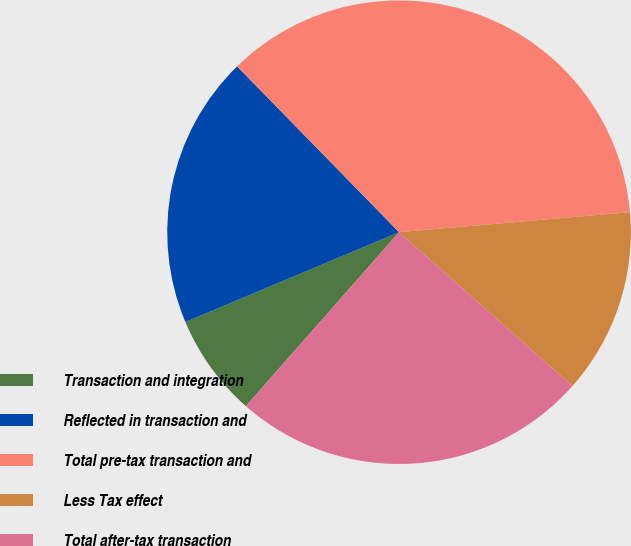<chart> <loc_0><loc_0><loc_500><loc_500><pie_chart><fcel>Transaction and integration<fcel>Reflected in transaction and<fcel>Total pre-tax transaction and<fcel>Less Tax effect<fcel>Total after-tax transaction<nl><fcel>7.18%<fcel>19.02%<fcel>35.94%<fcel>12.93%<fcel>24.94%<nl></chart> 